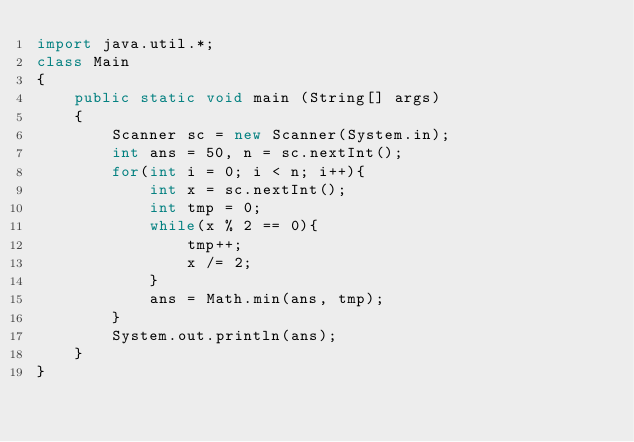<code> <loc_0><loc_0><loc_500><loc_500><_Java_>import java.util.*;
class Main
{
    public static void main (String[] args)
    {
        Scanner sc = new Scanner(System.in);
        int ans = 50, n = sc.nextInt();
        for(int i = 0; i < n; i++){
            int x = sc.nextInt();
            int tmp = 0;
            while(x % 2 == 0){
                tmp++;
                x /= 2;
            }
            ans = Math.min(ans, tmp);
        }
        System.out.println(ans);
    }
}</code> 